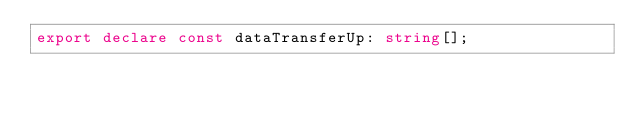Convert code to text. <code><loc_0><loc_0><loc_500><loc_500><_TypeScript_>export declare const dataTransferUp: string[];</code> 